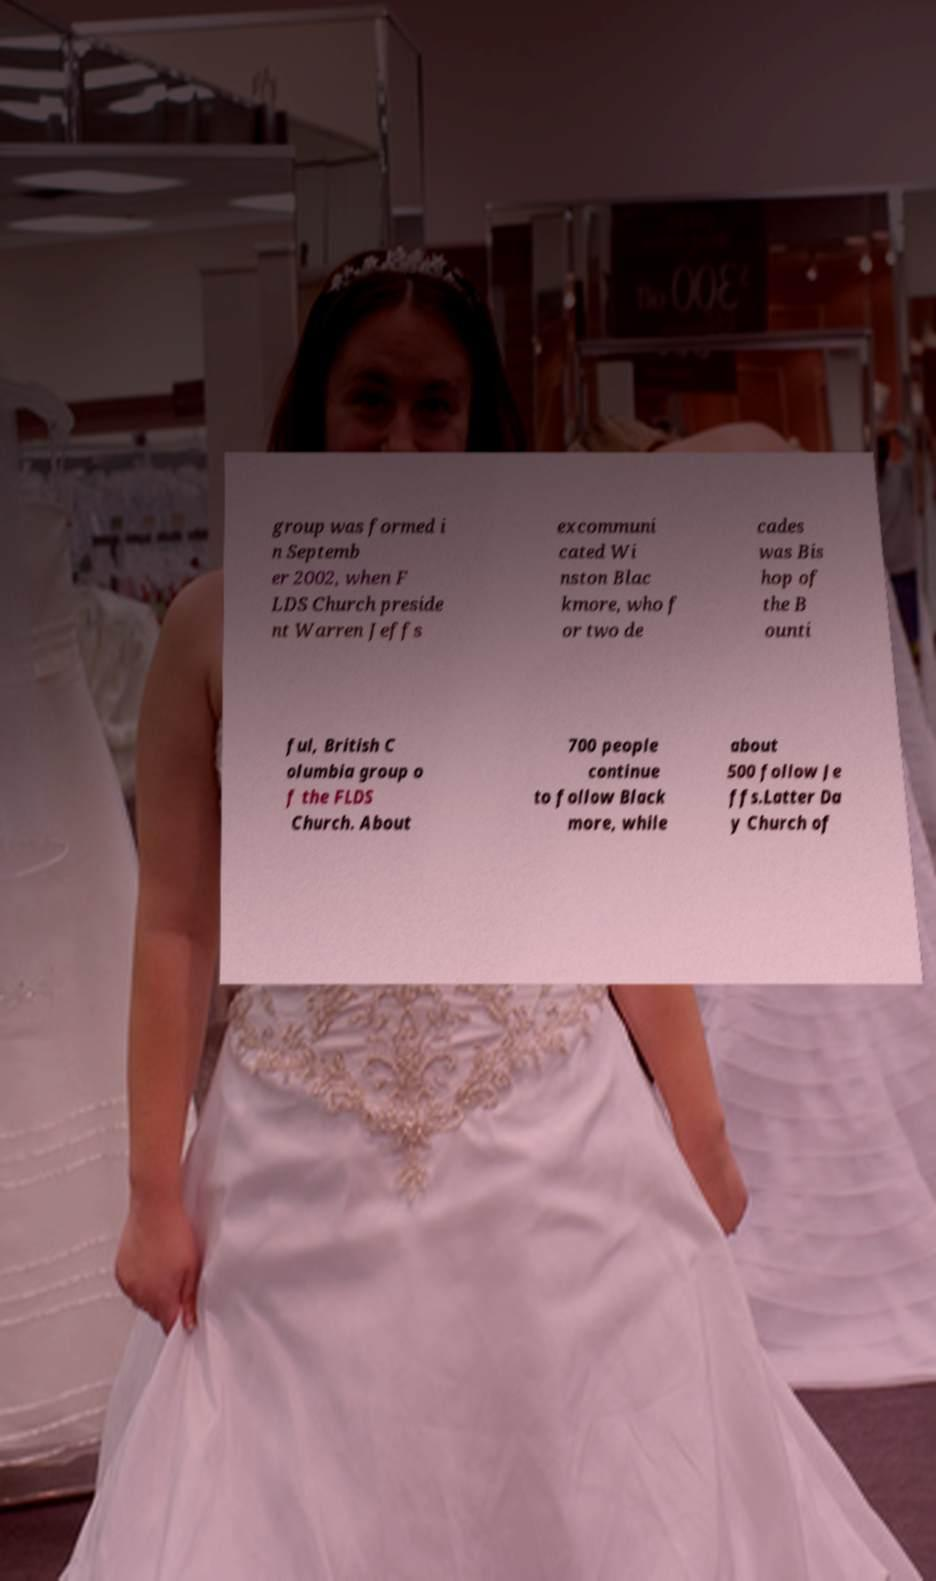Please read and relay the text visible in this image. What does it say? group was formed i n Septemb er 2002, when F LDS Church preside nt Warren Jeffs excommuni cated Wi nston Blac kmore, who f or two de cades was Bis hop of the B ounti ful, British C olumbia group o f the FLDS Church. About 700 people continue to follow Black more, while about 500 follow Je ffs.Latter Da y Church of 